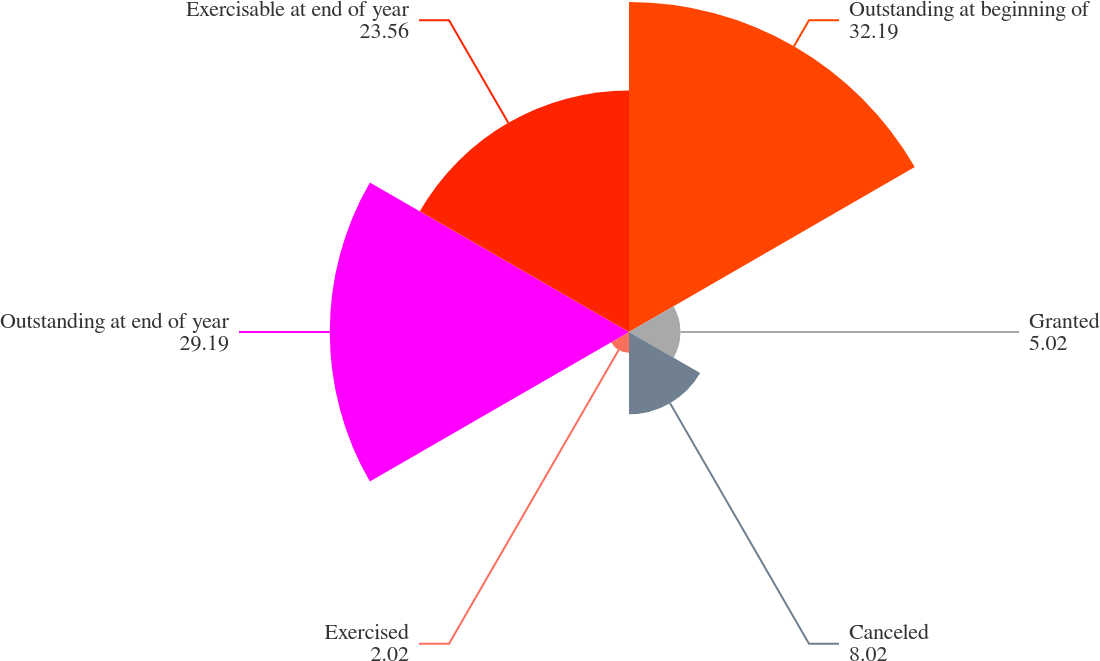Convert chart. <chart><loc_0><loc_0><loc_500><loc_500><pie_chart><fcel>Outstanding at beginning of<fcel>Granted<fcel>Canceled<fcel>Exercised<fcel>Outstanding at end of year<fcel>Exercisable at end of year<nl><fcel>32.19%<fcel>5.02%<fcel>8.02%<fcel>2.02%<fcel>29.19%<fcel>23.56%<nl></chart> 